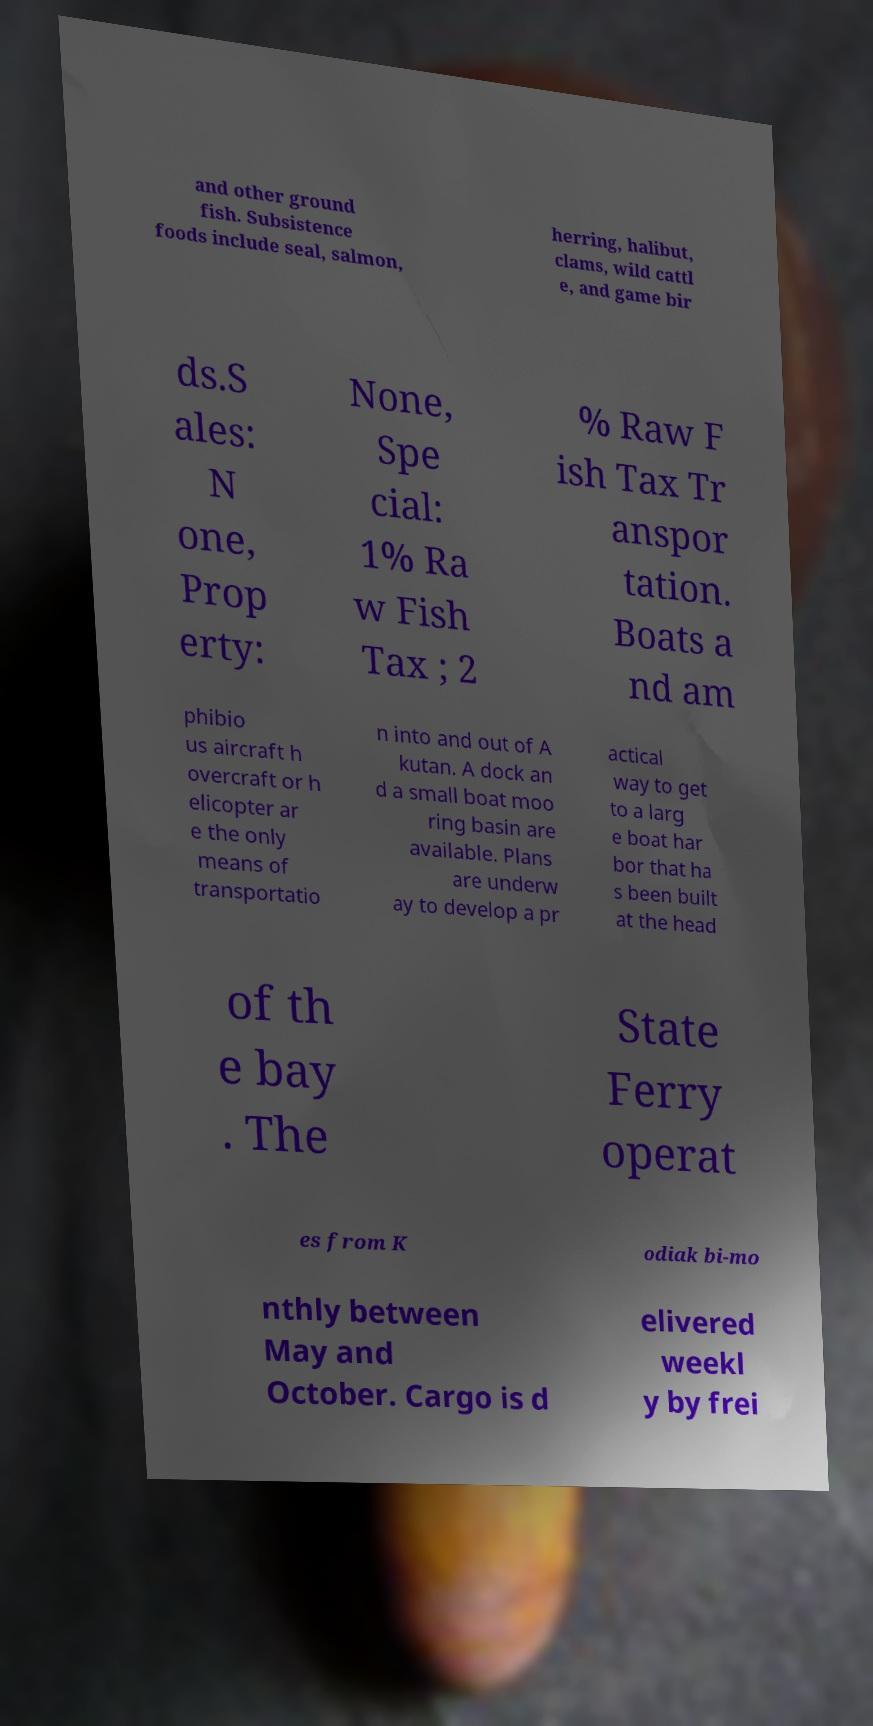I need the written content from this picture converted into text. Can you do that? and other ground fish. Subsistence foods include seal, salmon, herring, halibut, clams, wild cattl e, and game bir ds.S ales: N one, Prop erty: None, Spe cial: 1% Ra w Fish Tax ; 2 % Raw F ish Tax Tr anspor tation. Boats a nd am phibio us aircraft h overcraft or h elicopter ar e the only means of transportatio n into and out of A kutan. A dock an d a small boat moo ring basin are available. Plans are underw ay to develop a pr actical way to get to a larg e boat har bor that ha s been built at the head of th e bay . The State Ferry operat es from K odiak bi-mo nthly between May and October. Cargo is d elivered weekl y by frei 